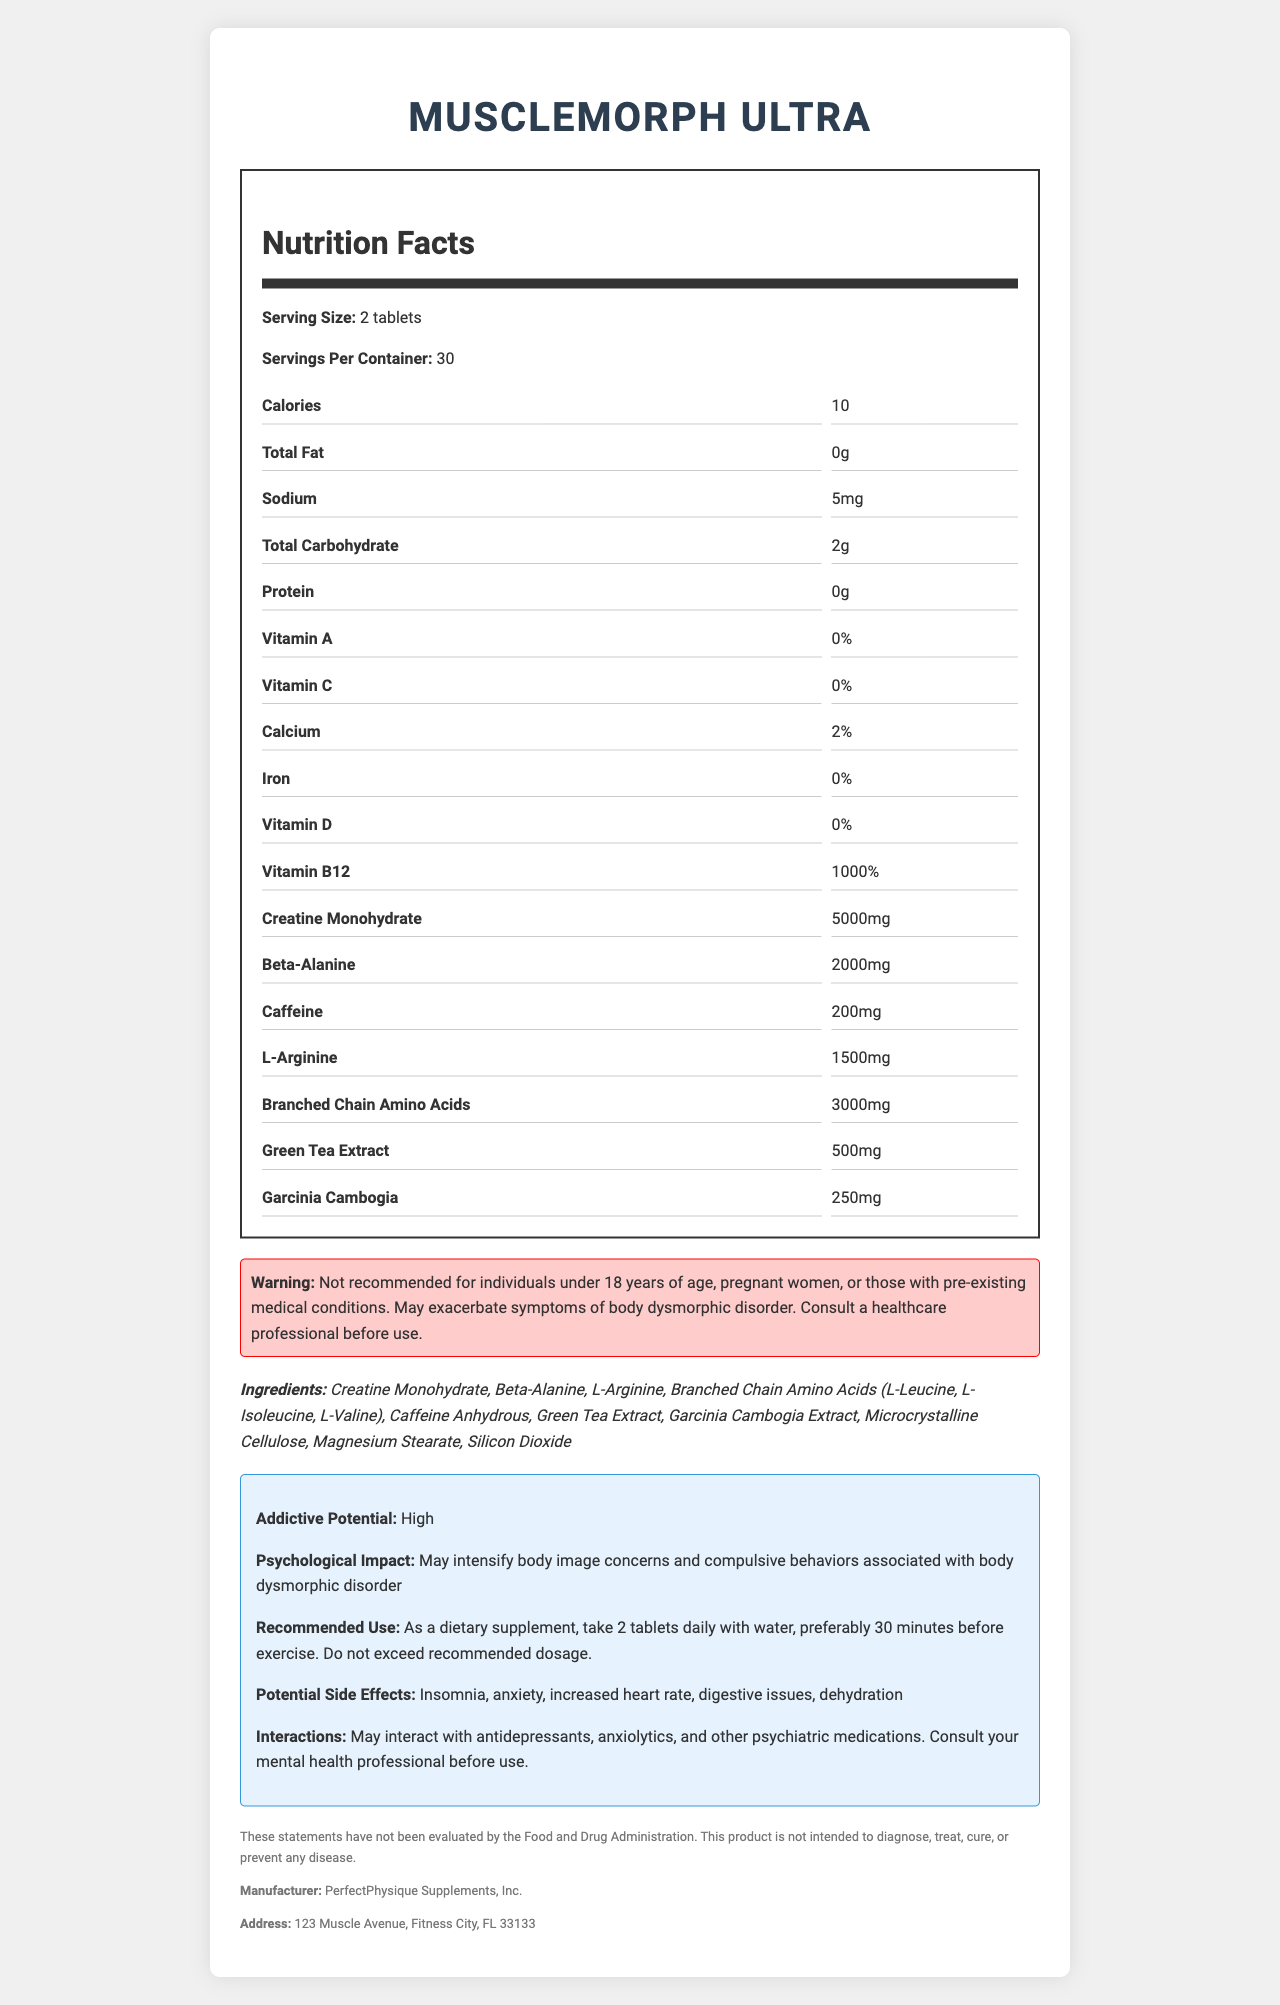what is the serving size of MuscleMorph Ultra? The serving size is specified as "2 tablets" in the Nutrition Facts section.
Answer: 2 tablets how many calories are in each serving? The document states that there are "10" calories per serving.
Answer: 10 which nutrient has the highest percentage of daily value? Vitamin B12 has the highest percentage of daily value at "1000%."
Answer: Vitamin B12 what is the total carbohydrate content per serving? The total carbohydrate content per serving is listed as "2g."
Answer: 2g who is the manufacturer of MuscleMorph Ultra? The manufacturer is specified as "PerfectPhysique Supplements, Inc."
Answer: PerfectPhysique Supplements, Inc. what are the potential side effects of using this supplement? A. Insomnia, anxiety B. Increased appetite, weight loss C. Hair loss, nausea D. Muscle gain, improved mood The potential side effects listed are "Insomnia, anxiety, increased heart rate, digestive issues, dehydration," which fall under option A.
Answer: A what should individuals under 18 years of age do before using MuscleMorph Ultra? A. Nothing, it's safe for them B. Check the dosage C. Avoid using it D. Consult with a fitness trainer The warning states "Not recommended for individuals under 18 years of age," so they should avoid using it.
Answer: C is MuscleMorph Ultra recommended for pregnant women? The warning clearly states that it is not recommended for pregnant women.
Answer: No does the document mention the address of the manufacturer? The manufacturer's address is mentioned as "123 Muscle Avenue, Fitness City, FL 33133."
Answer: Yes are there any interactions with psychiatric medications? The document mentions "May interact with antidepressants, anxiolytics, and other psychiatric medications."
Answer: Yes summarize the main idea of the document. The document outlines the serving size, key nutrients, ingredients, and warnings for MuscleMorph Ultra. It highlights high levels of various compounds like creatine, beta-alanine, and caffeine and notes that it may interact with psychiatric medications and worsen body dysmorphic disorder symptoms.
Answer: The document provides a comprehensive overview of the nutritional content, potential side effects, and warnings associated with the supplement MuscleMorph Ultra. It includes detailed nutrition facts, potential interactions with psychiatric medications, and a disclaimer noting high addictive potential and psychological impact on body image disorders. which ingredient is used in the highest amount per serving? Creatine Monohydrate is used in the highest amount at "5000mg" per serving.
Answer: Creatine Monohydrate can the document determine the effectiveness of the supplement for muscle gain? The document does not provide studies or evidence on the effectiveness of the supplement for muscle gain.
Answer: Not enough information 